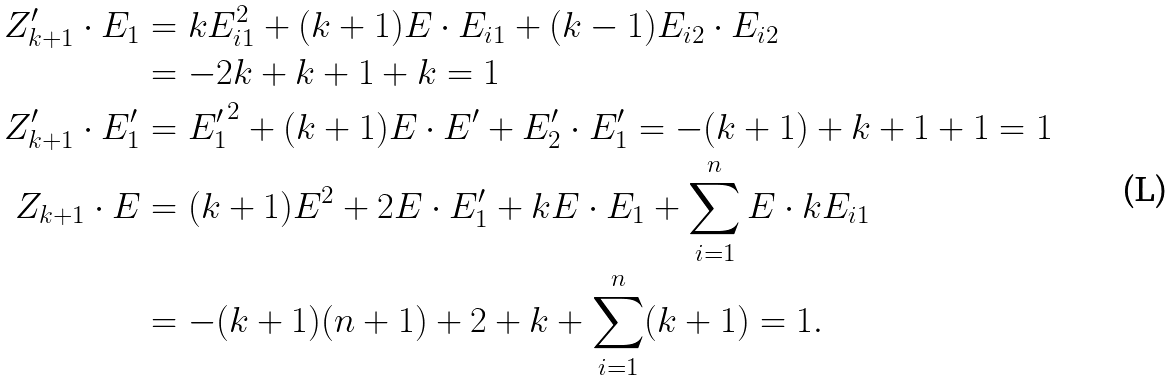Convert formula to latex. <formula><loc_0><loc_0><loc_500><loc_500>Z _ { k + 1 } ^ { \prime } \cdot E _ { 1 } & = k E _ { i 1 } ^ { 2 } + ( k + 1 ) E \cdot E _ { i 1 } + ( k - 1 ) E _ { i 2 } \cdot E _ { i 2 } \\ & = - 2 k + k + 1 + k = 1 \\ Z _ { k + 1 } ^ { \prime } \cdot E ^ { \prime } _ { 1 } & = { E ^ { \prime } _ { 1 } } ^ { 2 } + ( k + 1 ) E \cdot E ^ { \prime } + E _ { 2 } ^ { \prime } \cdot E ^ { \prime } _ { 1 } = - ( k + 1 ) + k + 1 + 1 = 1 \\ Z _ { k + 1 } \cdot E & = ( k + 1 ) E ^ { 2 } + 2 E \cdot E ^ { \prime } _ { 1 } + k E \cdot E _ { 1 } + \sum _ { i = 1 } ^ { n } E \cdot k E _ { i 1 } \\ & = - ( k + 1 ) ( n + 1 ) + 2 + k + \sum _ { i = 1 } ^ { n } ( k + 1 ) = 1 .</formula> 